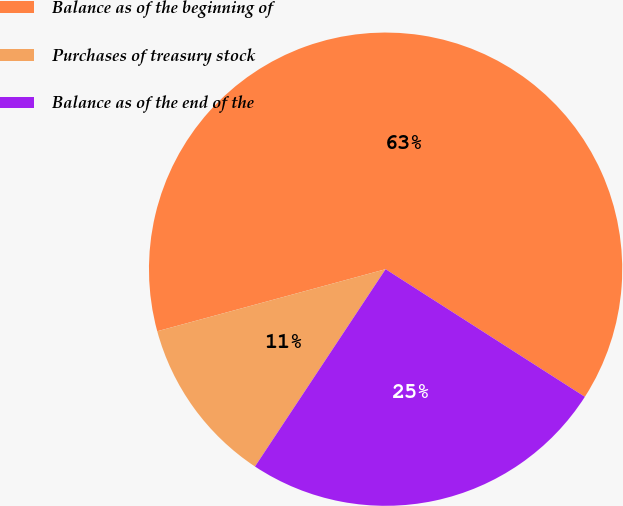Convert chart to OTSL. <chart><loc_0><loc_0><loc_500><loc_500><pie_chart><fcel>Balance as of the beginning of<fcel>Purchases of treasury stock<fcel>Balance as of the end of the<nl><fcel>63.29%<fcel>11.47%<fcel>25.24%<nl></chart> 